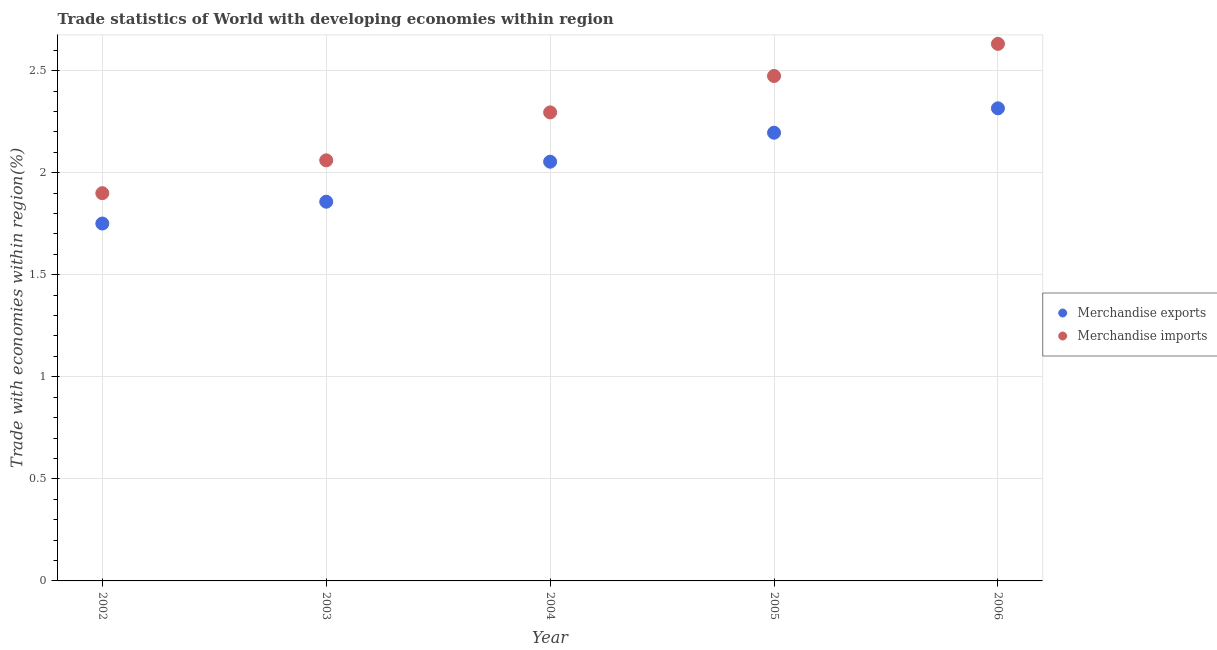How many different coloured dotlines are there?
Offer a very short reply. 2. What is the merchandise imports in 2005?
Provide a succinct answer. 2.47. Across all years, what is the maximum merchandise exports?
Your response must be concise. 2.32. Across all years, what is the minimum merchandise imports?
Offer a terse response. 1.9. In which year was the merchandise exports maximum?
Provide a succinct answer. 2006. In which year was the merchandise imports minimum?
Provide a succinct answer. 2002. What is the total merchandise exports in the graph?
Provide a short and direct response. 10.17. What is the difference between the merchandise imports in 2003 and that in 2006?
Ensure brevity in your answer.  -0.57. What is the difference between the merchandise exports in 2002 and the merchandise imports in 2004?
Keep it short and to the point. -0.54. What is the average merchandise imports per year?
Ensure brevity in your answer.  2.27. In the year 2004, what is the difference between the merchandise imports and merchandise exports?
Ensure brevity in your answer.  0.24. What is the ratio of the merchandise imports in 2002 to that in 2004?
Provide a short and direct response. 0.83. Is the difference between the merchandise exports in 2002 and 2004 greater than the difference between the merchandise imports in 2002 and 2004?
Provide a succinct answer. Yes. What is the difference between the highest and the second highest merchandise imports?
Offer a very short reply. 0.16. What is the difference between the highest and the lowest merchandise exports?
Your answer should be compact. 0.56. In how many years, is the merchandise exports greater than the average merchandise exports taken over all years?
Your response must be concise. 3. Is the sum of the merchandise exports in 2002 and 2003 greater than the maximum merchandise imports across all years?
Provide a succinct answer. Yes. How many dotlines are there?
Your response must be concise. 2. How many years are there in the graph?
Your response must be concise. 5. What is the difference between two consecutive major ticks on the Y-axis?
Offer a terse response. 0.5. Are the values on the major ticks of Y-axis written in scientific E-notation?
Your answer should be compact. No. Does the graph contain any zero values?
Your answer should be very brief. No. Does the graph contain grids?
Your response must be concise. Yes. Where does the legend appear in the graph?
Ensure brevity in your answer.  Center right. How many legend labels are there?
Offer a very short reply. 2. How are the legend labels stacked?
Ensure brevity in your answer.  Vertical. What is the title of the graph?
Your response must be concise. Trade statistics of World with developing economies within region. Does "Import" appear as one of the legend labels in the graph?
Keep it short and to the point. No. What is the label or title of the Y-axis?
Offer a very short reply. Trade with economies within region(%). What is the Trade with economies within region(%) in Merchandise exports in 2002?
Keep it short and to the point. 1.75. What is the Trade with economies within region(%) in Merchandise imports in 2002?
Provide a short and direct response. 1.9. What is the Trade with economies within region(%) of Merchandise exports in 2003?
Offer a very short reply. 1.86. What is the Trade with economies within region(%) in Merchandise imports in 2003?
Your answer should be very brief. 2.06. What is the Trade with economies within region(%) of Merchandise exports in 2004?
Keep it short and to the point. 2.05. What is the Trade with economies within region(%) in Merchandise imports in 2004?
Keep it short and to the point. 2.3. What is the Trade with economies within region(%) in Merchandise exports in 2005?
Offer a terse response. 2.2. What is the Trade with economies within region(%) in Merchandise imports in 2005?
Keep it short and to the point. 2.47. What is the Trade with economies within region(%) in Merchandise exports in 2006?
Your answer should be very brief. 2.32. What is the Trade with economies within region(%) of Merchandise imports in 2006?
Offer a terse response. 2.63. Across all years, what is the maximum Trade with economies within region(%) of Merchandise exports?
Your answer should be compact. 2.32. Across all years, what is the maximum Trade with economies within region(%) of Merchandise imports?
Ensure brevity in your answer.  2.63. Across all years, what is the minimum Trade with economies within region(%) of Merchandise exports?
Provide a succinct answer. 1.75. Across all years, what is the minimum Trade with economies within region(%) in Merchandise imports?
Offer a very short reply. 1.9. What is the total Trade with economies within region(%) in Merchandise exports in the graph?
Your answer should be compact. 10.17. What is the total Trade with economies within region(%) in Merchandise imports in the graph?
Make the answer very short. 11.36. What is the difference between the Trade with economies within region(%) of Merchandise exports in 2002 and that in 2003?
Offer a terse response. -0.11. What is the difference between the Trade with economies within region(%) of Merchandise imports in 2002 and that in 2003?
Your answer should be very brief. -0.16. What is the difference between the Trade with economies within region(%) of Merchandise exports in 2002 and that in 2004?
Offer a terse response. -0.3. What is the difference between the Trade with economies within region(%) of Merchandise imports in 2002 and that in 2004?
Offer a very short reply. -0.4. What is the difference between the Trade with economies within region(%) of Merchandise exports in 2002 and that in 2005?
Your answer should be very brief. -0.45. What is the difference between the Trade with economies within region(%) in Merchandise imports in 2002 and that in 2005?
Provide a short and direct response. -0.57. What is the difference between the Trade with economies within region(%) of Merchandise exports in 2002 and that in 2006?
Provide a succinct answer. -0.56. What is the difference between the Trade with economies within region(%) in Merchandise imports in 2002 and that in 2006?
Your answer should be very brief. -0.73. What is the difference between the Trade with economies within region(%) in Merchandise exports in 2003 and that in 2004?
Offer a very short reply. -0.2. What is the difference between the Trade with economies within region(%) of Merchandise imports in 2003 and that in 2004?
Provide a succinct answer. -0.23. What is the difference between the Trade with economies within region(%) in Merchandise exports in 2003 and that in 2005?
Ensure brevity in your answer.  -0.34. What is the difference between the Trade with economies within region(%) of Merchandise imports in 2003 and that in 2005?
Offer a very short reply. -0.41. What is the difference between the Trade with economies within region(%) in Merchandise exports in 2003 and that in 2006?
Ensure brevity in your answer.  -0.46. What is the difference between the Trade with economies within region(%) of Merchandise imports in 2003 and that in 2006?
Give a very brief answer. -0.57. What is the difference between the Trade with economies within region(%) in Merchandise exports in 2004 and that in 2005?
Provide a succinct answer. -0.14. What is the difference between the Trade with economies within region(%) in Merchandise imports in 2004 and that in 2005?
Keep it short and to the point. -0.18. What is the difference between the Trade with economies within region(%) in Merchandise exports in 2004 and that in 2006?
Ensure brevity in your answer.  -0.26. What is the difference between the Trade with economies within region(%) of Merchandise imports in 2004 and that in 2006?
Provide a succinct answer. -0.34. What is the difference between the Trade with economies within region(%) in Merchandise exports in 2005 and that in 2006?
Your response must be concise. -0.12. What is the difference between the Trade with economies within region(%) of Merchandise imports in 2005 and that in 2006?
Offer a terse response. -0.16. What is the difference between the Trade with economies within region(%) of Merchandise exports in 2002 and the Trade with economies within region(%) of Merchandise imports in 2003?
Ensure brevity in your answer.  -0.31. What is the difference between the Trade with economies within region(%) of Merchandise exports in 2002 and the Trade with economies within region(%) of Merchandise imports in 2004?
Ensure brevity in your answer.  -0.54. What is the difference between the Trade with economies within region(%) of Merchandise exports in 2002 and the Trade with economies within region(%) of Merchandise imports in 2005?
Your answer should be very brief. -0.72. What is the difference between the Trade with economies within region(%) in Merchandise exports in 2002 and the Trade with economies within region(%) in Merchandise imports in 2006?
Keep it short and to the point. -0.88. What is the difference between the Trade with economies within region(%) of Merchandise exports in 2003 and the Trade with economies within region(%) of Merchandise imports in 2004?
Your answer should be compact. -0.44. What is the difference between the Trade with economies within region(%) in Merchandise exports in 2003 and the Trade with economies within region(%) in Merchandise imports in 2005?
Provide a short and direct response. -0.62. What is the difference between the Trade with economies within region(%) of Merchandise exports in 2003 and the Trade with economies within region(%) of Merchandise imports in 2006?
Your response must be concise. -0.77. What is the difference between the Trade with economies within region(%) in Merchandise exports in 2004 and the Trade with economies within region(%) in Merchandise imports in 2005?
Make the answer very short. -0.42. What is the difference between the Trade with economies within region(%) in Merchandise exports in 2004 and the Trade with economies within region(%) in Merchandise imports in 2006?
Make the answer very short. -0.58. What is the difference between the Trade with economies within region(%) of Merchandise exports in 2005 and the Trade with economies within region(%) of Merchandise imports in 2006?
Give a very brief answer. -0.44. What is the average Trade with economies within region(%) of Merchandise exports per year?
Your answer should be compact. 2.03. What is the average Trade with economies within region(%) of Merchandise imports per year?
Give a very brief answer. 2.27. In the year 2002, what is the difference between the Trade with economies within region(%) of Merchandise exports and Trade with economies within region(%) of Merchandise imports?
Make the answer very short. -0.15. In the year 2003, what is the difference between the Trade with economies within region(%) in Merchandise exports and Trade with economies within region(%) in Merchandise imports?
Provide a short and direct response. -0.2. In the year 2004, what is the difference between the Trade with economies within region(%) in Merchandise exports and Trade with economies within region(%) in Merchandise imports?
Ensure brevity in your answer.  -0.24. In the year 2005, what is the difference between the Trade with economies within region(%) of Merchandise exports and Trade with economies within region(%) of Merchandise imports?
Offer a very short reply. -0.28. In the year 2006, what is the difference between the Trade with economies within region(%) of Merchandise exports and Trade with economies within region(%) of Merchandise imports?
Your answer should be very brief. -0.32. What is the ratio of the Trade with economies within region(%) in Merchandise exports in 2002 to that in 2003?
Make the answer very short. 0.94. What is the ratio of the Trade with economies within region(%) in Merchandise imports in 2002 to that in 2003?
Provide a short and direct response. 0.92. What is the ratio of the Trade with economies within region(%) in Merchandise exports in 2002 to that in 2004?
Your answer should be very brief. 0.85. What is the ratio of the Trade with economies within region(%) in Merchandise imports in 2002 to that in 2004?
Offer a very short reply. 0.83. What is the ratio of the Trade with economies within region(%) in Merchandise exports in 2002 to that in 2005?
Offer a terse response. 0.8. What is the ratio of the Trade with economies within region(%) in Merchandise imports in 2002 to that in 2005?
Ensure brevity in your answer.  0.77. What is the ratio of the Trade with economies within region(%) of Merchandise exports in 2002 to that in 2006?
Your response must be concise. 0.76. What is the ratio of the Trade with economies within region(%) of Merchandise imports in 2002 to that in 2006?
Keep it short and to the point. 0.72. What is the ratio of the Trade with economies within region(%) in Merchandise exports in 2003 to that in 2004?
Offer a very short reply. 0.9. What is the ratio of the Trade with economies within region(%) of Merchandise imports in 2003 to that in 2004?
Provide a succinct answer. 0.9. What is the ratio of the Trade with economies within region(%) of Merchandise exports in 2003 to that in 2005?
Give a very brief answer. 0.85. What is the ratio of the Trade with economies within region(%) of Merchandise imports in 2003 to that in 2005?
Offer a very short reply. 0.83. What is the ratio of the Trade with economies within region(%) of Merchandise exports in 2003 to that in 2006?
Give a very brief answer. 0.8. What is the ratio of the Trade with economies within region(%) in Merchandise imports in 2003 to that in 2006?
Your response must be concise. 0.78. What is the ratio of the Trade with economies within region(%) in Merchandise exports in 2004 to that in 2005?
Your answer should be very brief. 0.94. What is the ratio of the Trade with economies within region(%) of Merchandise imports in 2004 to that in 2005?
Provide a succinct answer. 0.93. What is the ratio of the Trade with economies within region(%) in Merchandise exports in 2004 to that in 2006?
Ensure brevity in your answer.  0.89. What is the ratio of the Trade with economies within region(%) of Merchandise imports in 2004 to that in 2006?
Provide a short and direct response. 0.87. What is the ratio of the Trade with economies within region(%) in Merchandise exports in 2005 to that in 2006?
Ensure brevity in your answer.  0.95. What is the ratio of the Trade with economies within region(%) of Merchandise imports in 2005 to that in 2006?
Your answer should be compact. 0.94. What is the difference between the highest and the second highest Trade with economies within region(%) in Merchandise exports?
Provide a succinct answer. 0.12. What is the difference between the highest and the second highest Trade with economies within region(%) of Merchandise imports?
Offer a terse response. 0.16. What is the difference between the highest and the lowest Trade with economies within region(%) of Merchandise exports?
Provide a succinct answer. 0.56. What is the difference between the highest and the lowest Trade with economies within region(%) of Merchandise imports?
Provide a short and direct response. 0.73. 